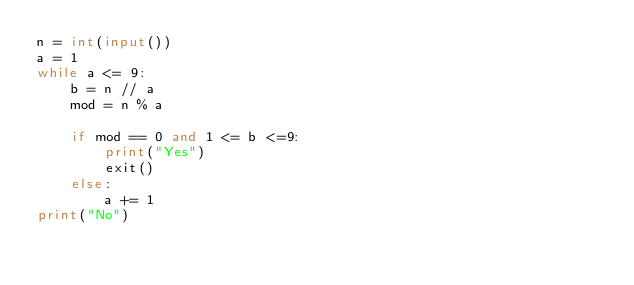Convert code to text. <code><loc_0><loc_0><loc_500><loc_500><_Python_>n = int(input())
a = 1
while a <= 9:
    b = n // a
    mod = n % a
    
    if mod == 0 and 1 <= b <=9:
        print("Yes")
        exit()
    else:
        a += 1
print("No")</code> 